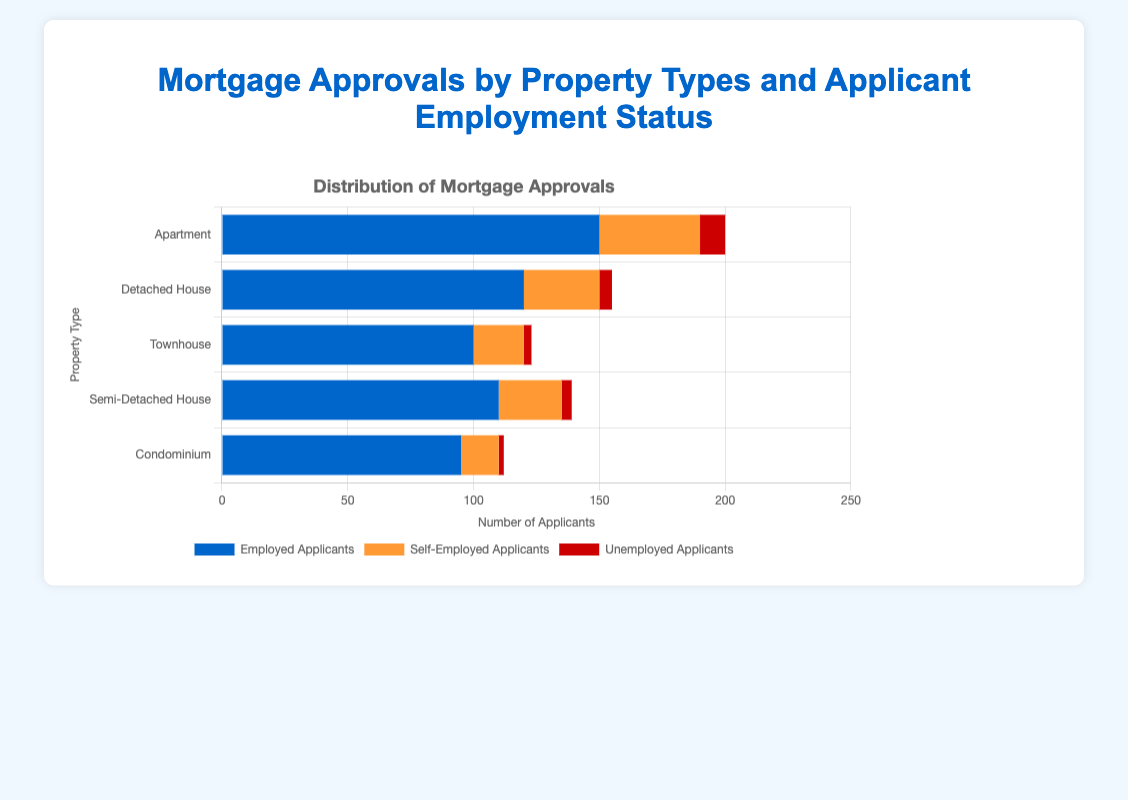Which property type has the most mortgage approvals from employed applicants? For employed applicants, the highest bar is for "Apartment," as indicated by the tallest blue bar.
Answer: Apartment What's the sum of mortgage approvals for self-employed applicants across all property types? Adding the values for self-employed applicants: 40 (Apartment) + 30 (Detached House) + 20 (Townhouse) + 25 (Semi-Detached House) + 15 (Condominium) = 130.
Answer: 130 Which property type has the least number of mortgage approvals for unemployed applicants? The property type with the smallest red bar is "Condominium," indicating the lowest approvals for unemployed applicants.
Answer: Condominium What is the difference between the number of approvals for employed applicants and self-employed applicants for Detached House? Subtracting the number of self-employed applicants from employed applicants for Detached House: 120 - 30 = 90.
Answer: 90 Compare the number of approvals for employed applicants between Semi-Detached House and Condominium. Which one is higher, and by how much? Semi-Detached House has 110 approvals and Condominium has 95. The difference is 110 - 95 = 15, with Semi-Detached House having more.
Answer: Semi-Detached House, by 15 What is the average number of approvals for unemployed applicants across all property types? Adding the numbers for unemployed applicants: 10 (Apartment) + 5 (Detached House) + 3 (Townhouse) + 4 (Semi-Detached House) + 2 (Condominium) = 24. Dividing by 5 property types gives an average: 24 / 5 = 4.8.
Answer: 4.8 What is the total number of mortgage approvals across all employment statuses for Townhouse? Adding the values for employed, self-employed, and unemployed applicants for Townhouse: 100 + 20 + 3 = 123.
Answer: 123 What is the ratio of approvals for employed to self-employed applicants for Apartment? For Apartment, the number of approvals are 150 (Employed) and 40 (Self-Employed). The ratio is 150:40, which can be simplified to 15:4.
Answer: 15:4 